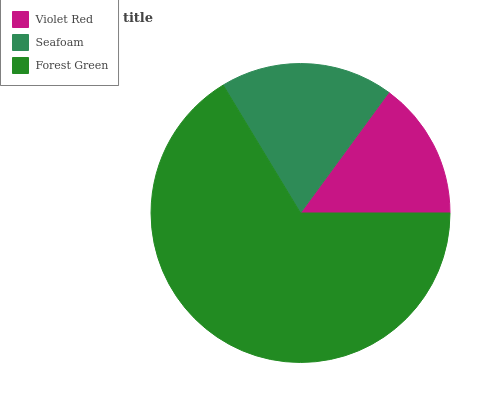Is Violet Red the minimum?
Answer yes or no. Yes. Is Forest Green the maximum?
Answer yes or no. Yes. Is Seafoam the minimum?
Answer yes or no. No. Is Seafoam the maximum?
Answer yes or no. No. Is Seafoam greater than Violet Red?
Answer yes or no. Yes. Is Violet Red less than Seafoam?
Answer yes or no. Yes. Is Violet Red greater than Seafoam?
Answer yes or no. No. Is Seafoam less than Violet Red?
Answer yes or no. No. Is Seafoam the high median?
Answer yes or no. Yes. Is Seafoam the low median?
Answer yes or no. Yes. Is Violet Red the high median?
Answer yes or no. No. Is Violet Red the low median?
Answer yes or no. No. 